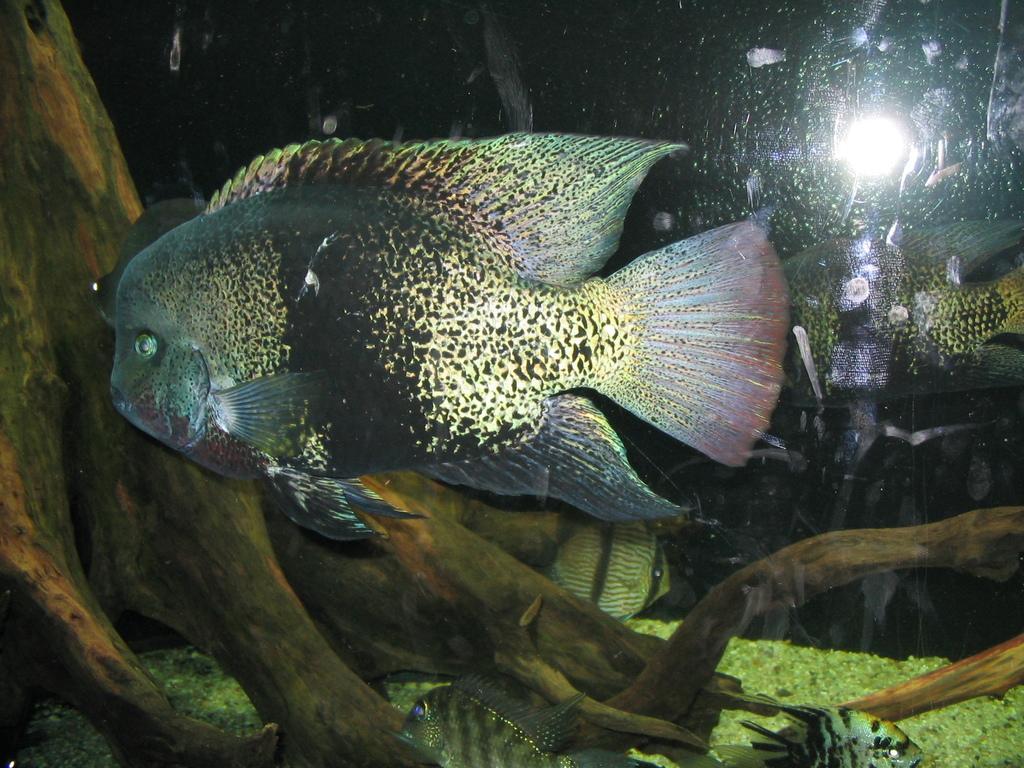Can you describe this image briefly? In this image in the center there is a fish, and in the background there are some fishes and at the bottom also there are fishes. And on the left side it looks like a tree, and on the right side there is a light. 